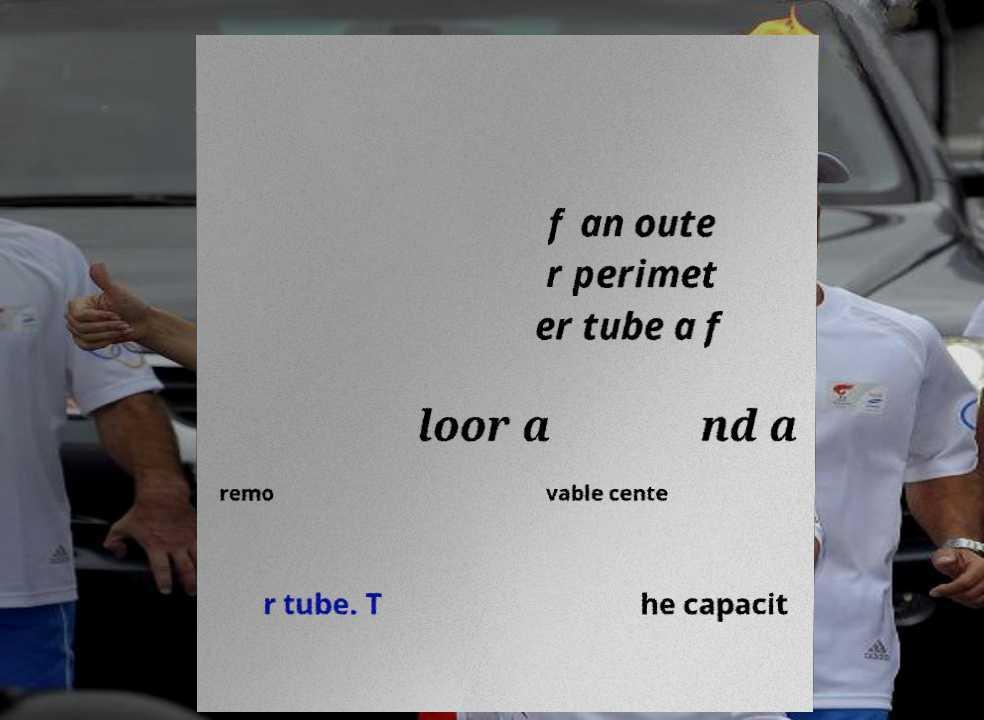Can you accurately transcribe the text from the provided image for me? f an oute r perimet er tube a f loor a nd a remo vable cente r tube. T he capacit 